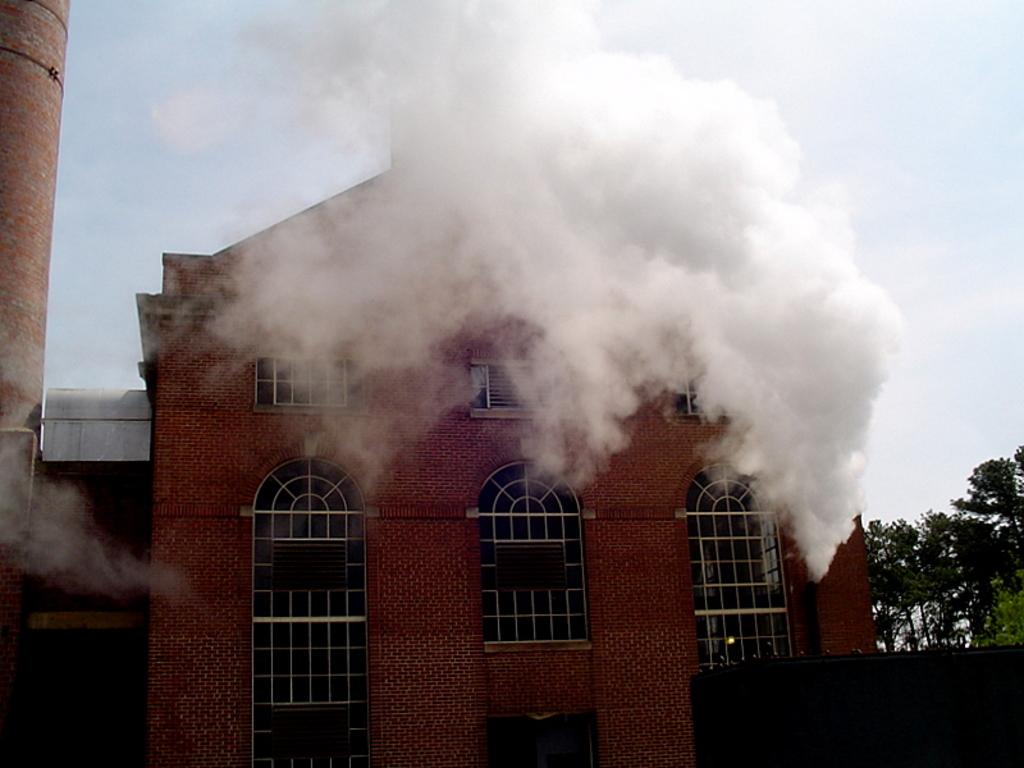What color is the building in the image? The building in the image is red. What can be seen in the front of the image? There is smoke in the front of the image. What type of vegetation is on the right side of the image? There are trees on the right side of the image. What is visible in the background of the image? Clouds and the sky are visible in the background of the image. How many ladybugs are crawling on the building in the image? There are no ladybugs present in the image. What type of train can be seen passing by the building in the image? There is no train visible in the image. 